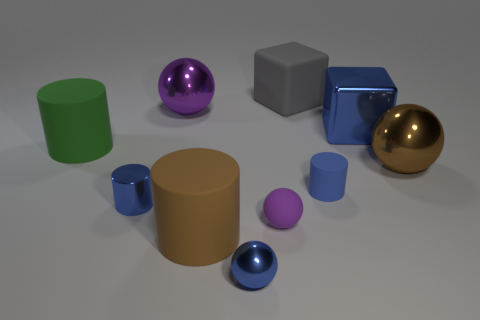Subtract 1 balls. How many balls are left? 3 Subtract all cylinders. How many objects are left? 6 Subtract 0 purple blocks. How many objects are left? 10 Subtract all small blue rubber objects. Subtract all brown matte cylinders. How many objects are left? 8 Add 5 large green cylinders. How many large green cylinders are left? 6 Add 9 big brown cylinders. How many big brown cylinders exist? 10 